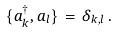Convert formula to latex. <formula><loc_0><loc_0><loc_500><loc_500>\{ a _ { k } ^ { \dagger } , a _ { l } \} \, = \, \delta _ { k , l } \, .</formula> 